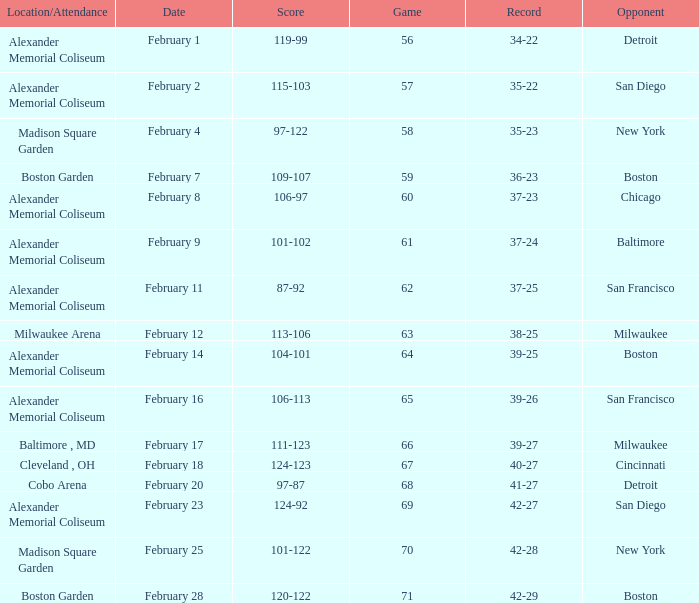What is the Game # that scored 87-92? 62.0. 